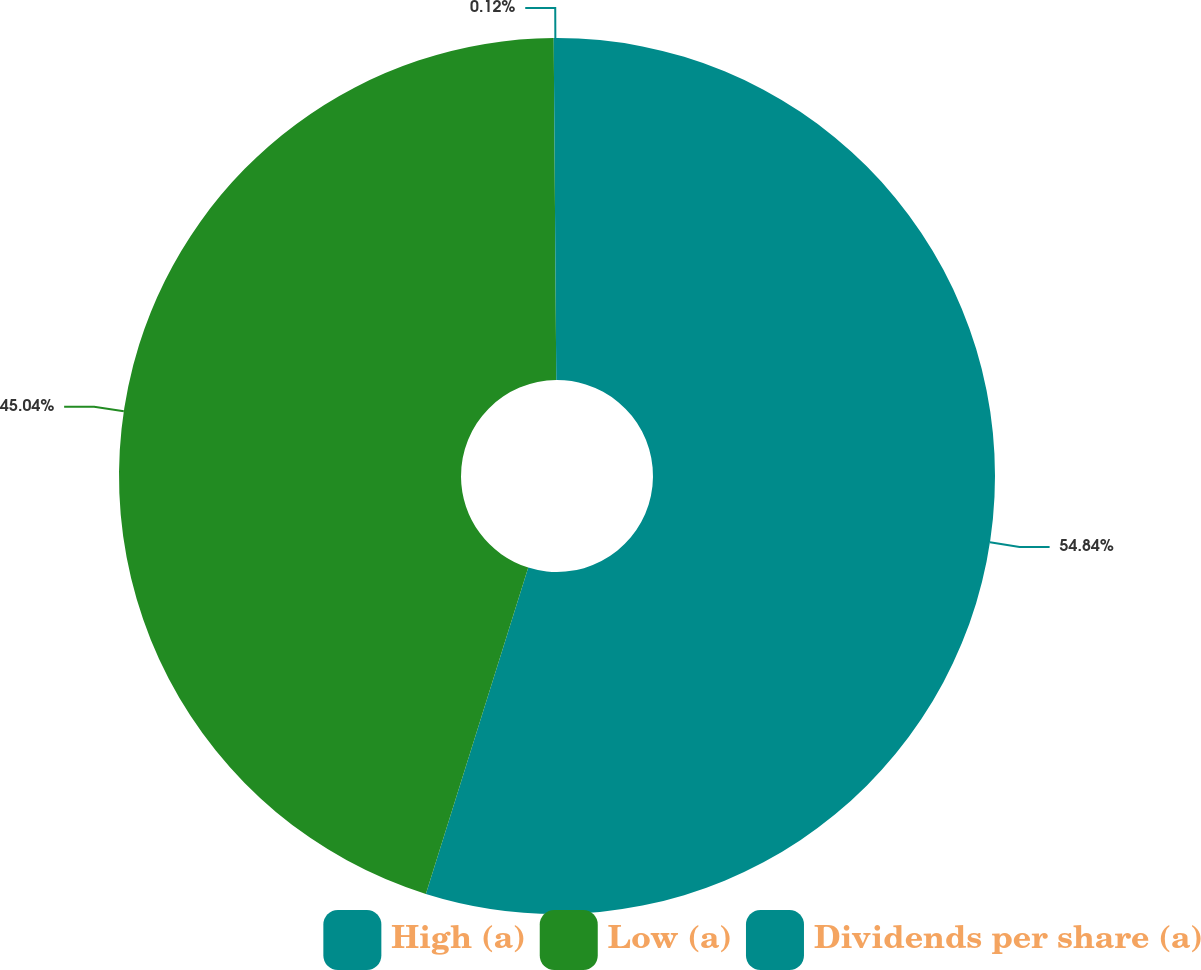Convert chart to OTSL. <chart><loc_0><loc_0><loc_500><loc_500><pie_chart><fcel>High (a)<fcel>Low (a)<fcel>Dividends per share (a)<nl><fcel>54.84%<fcel>45.04%<fcel>0.12%<nl></chart> 